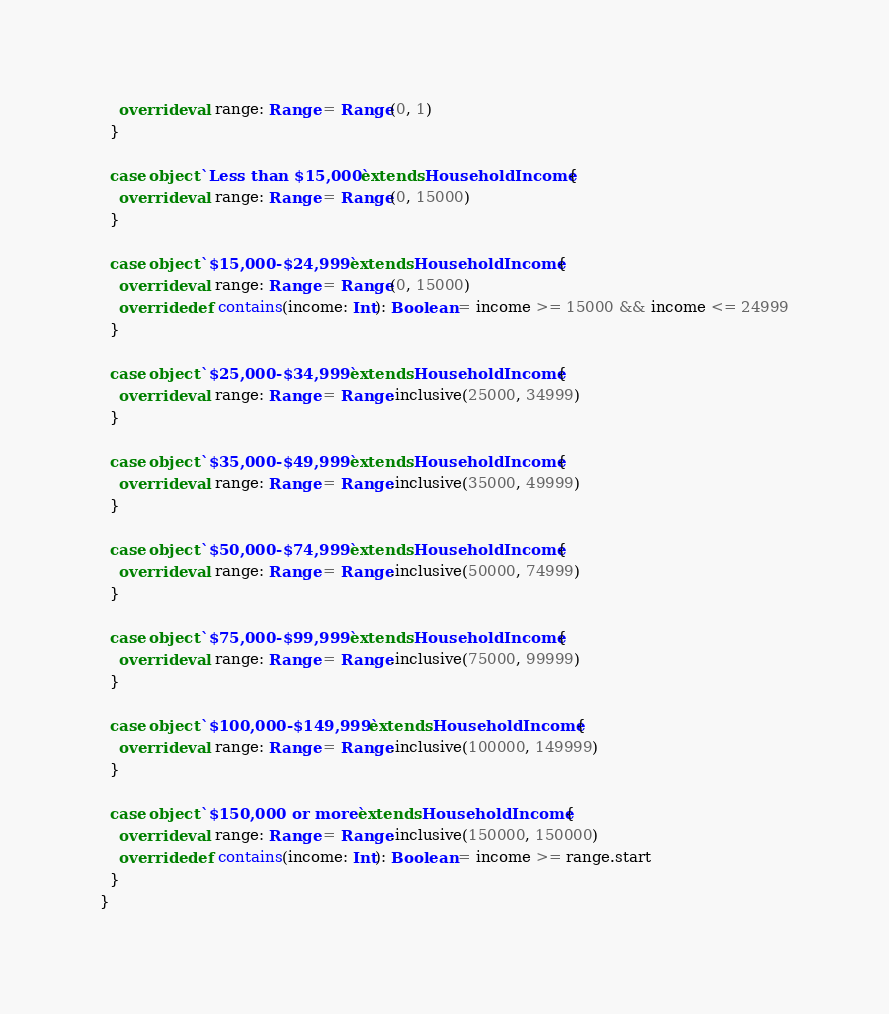<code> <loc_0><loc_0><loc_500><loc_500><_Scala_>    override val range: Range = Range(0, 1)
  }

  case object `Less than $15,000` extends HouseholdIncome {
    override val range: Range = Range(0, 15000)
  }

  case object `$15,000-$24,999` extends HouseholdIncome {
    override val range: Range = Range(0, 15000)
    override def contains(income: Int): Boolean = income >= 15000 && income <= 24999
  }

  case object `$25,000-$34,999` extends HouseholdIncome {
    override val range: Range = Range.inclusive(25000, 34999)
  }

  case object `$35,000-$49,999` extends HouseholdIncome {
    override val range: Range = Range.inclusive(35000, 49999)
  }

  case object `$50,000-$74,999` extends HouseholdIncome {
    override val range: Range = Range.inclusive(50000, 74999)
  }

  case object `$75,000-$99,999` extends HouseholdIncome {
    override val range: Range = Range.inclusive(75000, 99999)
  }

  case object `$100,000-$149,999` extends HouseholdIncome {
    override val range: Range = Range.inclusive(100000, 149999)
  }

  case object `$150,000 or more` extends HouseholdIncome {
    override val range: Range = Range.inclusive(150000, 150000)
    override def contains(income: Int): Boolean = income >= range.start
  }
}
</code> 